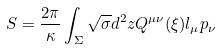<formula> <loc_0><loc_0><loc_500><loc_500>S = { \frac { 2 \pi } { \kappa } } \int _ { \Sigma } \sqrt { \sigma } d ^ { 2 } z Q ^ { \mu \nu } ( \xi ) l _ { \mu } p _ { \nu }</formula> 